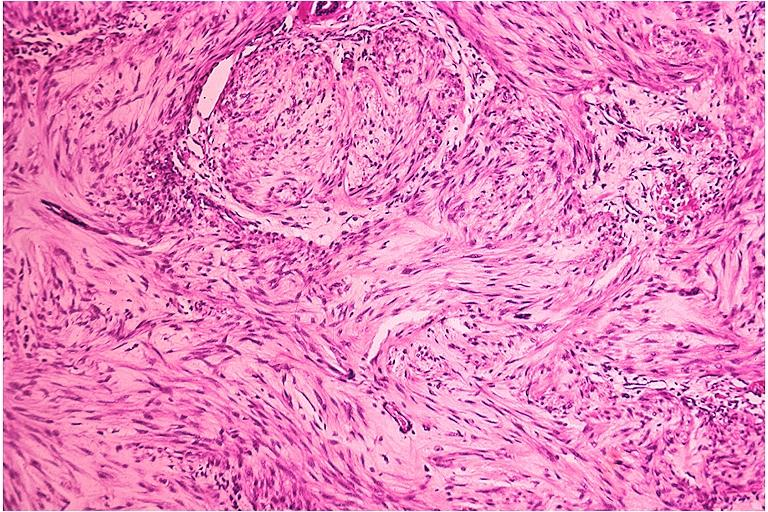does this image show neurofibroma?
Answer the question using a single word or phrase. Yes 